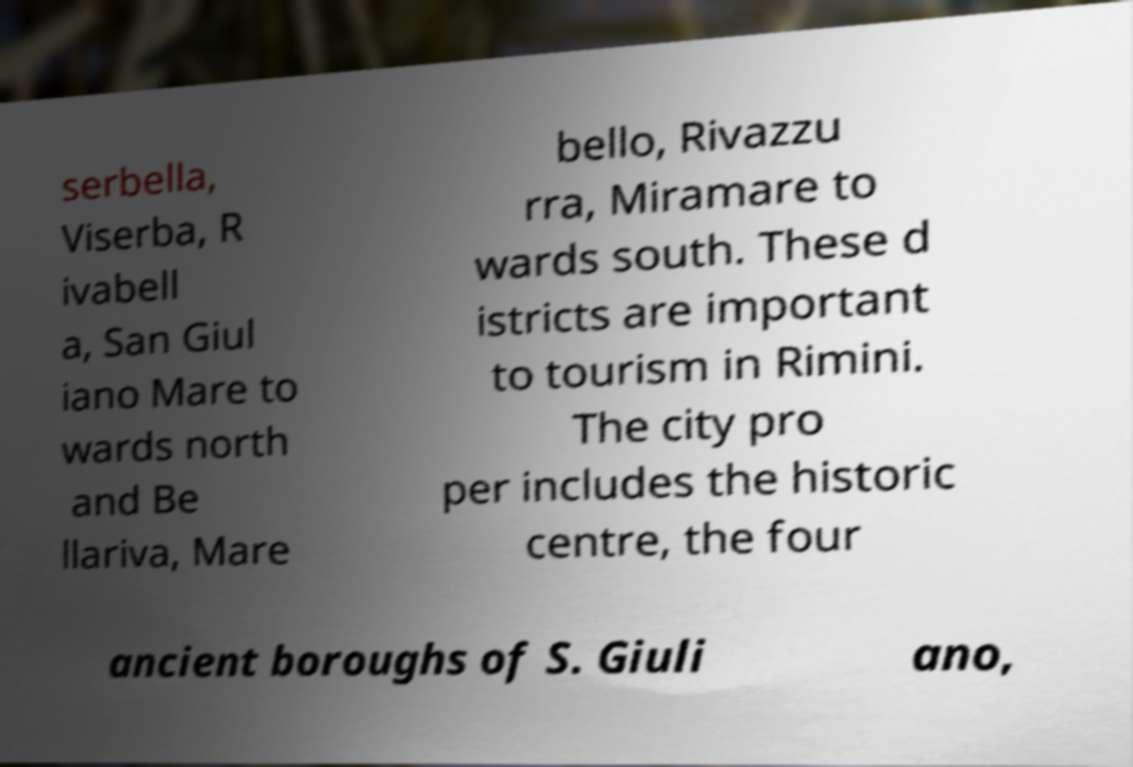Can you accurately transcribe the text from the provided image for me? serbella, Viserba, R ivabell a, San Giul iano Mare to wards north and Be llariva, Mare bello, Rivazzu rra, Miramare to wards south. These d istricts are important to tourism in Rimini. The city pro per includes the historic centre, the four ancient boroughs of S. Giuli ano, 